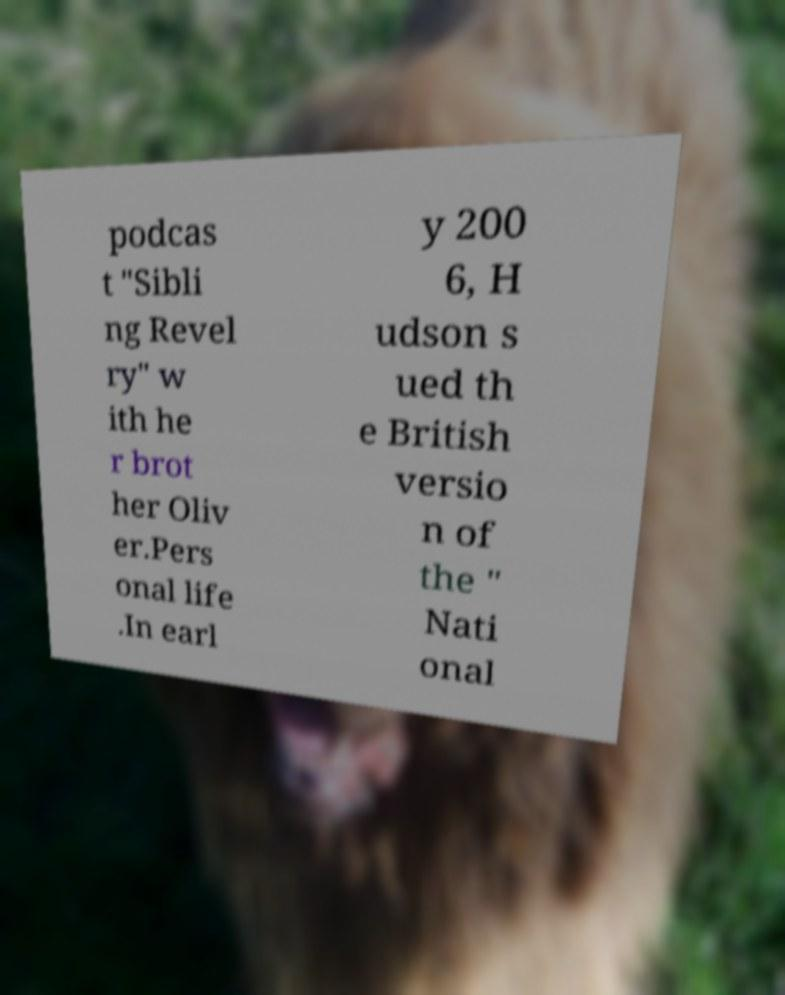Can you read and provide the text displayed in the image?This photo seems to have some interesting text. Can you extract and type it out for me? podcas t "Sibli ng Revel ry" w ith he r brot her Oliv er.Pers onal life .In earl y 200 6, H udson s ued th e British versio n of the " Nati onal 